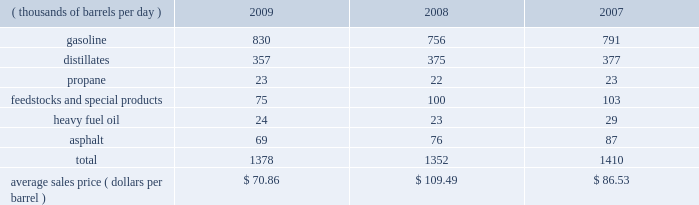The table sets forth our refined products sales by product group and our average sales price for each of the last three years .
Refined product sales ( thousands of barrels per day ) 2009 2008 2007 .
We sell gasoline , gasoline blendstocks and no .
1 and no .
2 fuel oils ( including kerosene , jet fuel and diesel fuel ) to wholesale marketing customers in the midwest , upper great plains , gulf coast and southeastern regions of the united states .
We sold 51 percent of our gasoline volumes and 87 percent of our distillates volumes on a wholesale or spot market basis in 2009 .
The demand for gasoline is seasonal in many of our markets , with demand typically being at its highest levels during the summer months .
We have blended ethanol into gasoline for over 20 years and began expanding our blending program in 2007 , in part due to federal regulations that require us to use specified volumes of renewable fuels .
Ethanol volumes sold in blended gasoline were 60 mbpd in 2009 , 54 mbpd in 2008 and 40 mbpd in 2007 .
The future expansion or contraction of our ethanol blending program will be driven by the economics of the ethanol supply and by government regulations .
We sell reformulated gasoline , which is also blended with ethanol , in parts of our marketing territory , including : chicago , illinois ; louisville , kentucky ; northern kentucky ; milwaukee , wisconsin , and hartford , illinois .
We also sell biodiesel-blended diesel in minnesota , illinois and kentucky .
We produce propane at all seven of our refineries .
Propane is primarily used for home heating and cooking , as a feedstock within the petrochemical industry , for grain drying and as a fuel for trucks and other vehicles .
Our propane sales are typically split evenly between the home heating market and industrial consumers .
We are a producer and marketer of petrochemicals and specialty products .
Product availability varies by refinery and includes benzene , cumene , dilute naphthalene oil , molten maleic anhydride , molten sulfur , propylene , toluene and xylene .
We market propylene , cumene and sulfur domestically to customers in the chemical industry .
We sell maleic anhydride throughout the united states and canada .
We also have the capacity to produce 1400 tons per day of anode grade coke at our robinson refinery , which is used to make carbon anodes for the aluminum smelting industry , and 5500 tons per day of fuel grade coke at the garyville refinery , which is used for power generation and in miscellaneous industrial applications .
In early 2009 , we discontinued production and sales of petroleum pitch and aliphatic solvents at our catlettsburg refinery .
We produce and market heavy residual fuel oil or related components at all seven of our refineries .
Another product of crude oil , heavy residual fuel oil , is primarily used in the utility and ship bunkering ( fuel ) industries , though there are other more specialized uses of the product .
We have refinery based asphalt production capacity of up to 108 mbpd .
We market asphalt through 33 owned or leased terminals throughout the midwest and southeast .
We have a broad customer base , including approximately 675 asphalt-paving contractors , government entities ( states , counties , cities and townships ) and asphalt roofing shingle manufacturers .
We sell asphalt in the wholesale and cargo markets via rail and barge .
We also produce asphalt cements , polymer modified asphalt , emulsified asphalt and industrial asphalts .
In 2007 , we acquired a 35 percent interest in an entity which owns and operates a 110-million-gallon-per-year ethanol production facility in clymers , indiana .
We also own a 50 percent interest in an entity which owns a 110-million-gallon-per-year ethanol production facility in greenville , ohio .
The greenville plant began production in february 2008 .
Both of these facilities are managed by a co-owner. .
What were total ethanol volumes sold in blended gasoline in 2009 , 2008 , and 2007 in tbd? 
Computations: ((60 + 54) + 40)
Answer: 154.0. The table sets forth our refined products sales by product group and our average sales price for each of the last three years .
Refined product sales ( thousands of barrels per day ) 2009 2008 2007 .
We sell gasoline , gasoline blendstocks and no .
1 and no .
2 fuel oils ( including kerosene , jet fuel and diesel fuel ) to wholesale marketing customers in the midwest , upper great plains , gulf coast and southeastern regions of the united states .
We sold 51 percent of our gasoline volumes and 87 percent of our distillates volumes on a wholesale or spot market basis in 2009 .
The demand for gasoline is seasonal in many of our markets , with demand typically being at its highest levels during the summer months .
We have blended ethanol into gasoline for over 20 years and began expanding our blending program in 2007 , in part due to federal regulations that require us to use specified volumes of renewable fuels .
Ethanol volumes sold in blended gasoline were 60 mbpd in 2009 , 54 mbpd in 2008 and 40 mbpd in 2007 .
The future expansion or contraction of our ethanol blending program will be driven by the economics of the ethanol supply and by government regulations .
We sell reformulated gasoline , which is also blended with ethanol , in parts of our marketing territory , including : chicago , illinois ; louisville , kentucky ; northern kentucky ; milwaukee , wisconsin , and hartford , illinois .
We also sell biodiesel-blended diesel in minnesota , illinois and kentucky .
We produce propane at all seven of our refineries .
Propane is primarily used for home heating and cooking , as a feedstock within the petrochemical industry , for grain drying and as a fuel for trucks and other vehicles .
Our propane sales are typically split evenly between the home heating market and industrial consumers .
We are a producer and marketer of petrochemicals and specialty products .
Product availability varies by refinery and includes benzene , cumene , dilute naphthalene oil , molten maleic anhydride , molten sulfur , propylene , toluene and xylene .
We market propylene , cumene and sulfur domestically to customers in the chemical industry .
We sell maleic anhydride throughout the united states and canada .
We also have the capacity to produce 1400 tons per day of anode grade coke at our robinson refinery , which is used to make carbon anodes for the aluminum smelting industry , and 5500 tons per day of fuel grade coke at the garyville refinery , which is used for power generation and in miscellaneous industrial applications .
In early 2009 , we discontinued production and sales of petroleum pitch and aliphatic solvents at our catlettsburg refinery .
We produce and market heavy residual fuel oil or related components at all seven of our refineries .
Another product of crude oil , heavy residual fuel oil , is primarily used in the utility and ship bunkering ( fuel ) industries , though there are other more specialized uses of the product .
We have refinery based asphalt production capacity of up to 108 mbpd .
We market asphalt through 33 owned or leased terminals throughout the midwest and southeast .
We have a broad customer base , including approximately 675 asphalt-paving contractors , government entities ( states , counties , cities and townships ) and asphalt roofing shingle manufacturers .
We sell asphalt in the wholesale and cargo markets via rail and barge .
We also produce asphalt cements , polymer modified asphalt , emulsified asphalt and industrial asphalts .
In 2007 , we acquired a 35 percent interest in an entity which owns and operates a 110-million-gallon-per-year ethanol production facility in clymers , indiana .
We also own a 50 percent interest in an entity which owns a 110-million-gallon-per-year ethanol production facility in greenville , ohio .
The greenville plant began production in february 2008 .
Both of these facilities are managed by a co-owner. .
What percentage of refined product sales consisted of asphalt in 2009? 
Computations: (69 / 1378)
Answer: 0.05007. The table sets forth our refined products sales by product group and our average sales price for each of the last three years .
Refined product sales ( thousands of barrels per day ) 2009 2008 2007 .
We sell gasoline , gasoline blendstocks and no .
1 and no .
2 fuel oils ( including kerosene , jet fuel and diesel fuel ) to wholesale marketing customers in the midwest , upper great plains , gulf coast and southeastern regions of the united states .
We sold 51 percent of our gasoline volumes and 87 percent of our distillates volumes on a wholesale or spot market basis in 2009 .
The demand for gasoline is seasonal in many of our markets , with demand typically being at its highest levels during the summer months .
We have blended ethanol into gasoline for over 20 years and began expanding our blending program in 2007 , in part due to federal regulations that require us to use specified volumes of renewable fuels .
Ethanol volumes sold in blended gasoline were 60 mbpd in 2009 , 54 mbpd in 2008 and 40 mbpd in 2007 .
The future expansion or contraction of our ethanol blending program will be driven by the economics of the ethanol supply and by government regulations .
We sell reformulated gasoline , which is also blended with ethanol , in parts of our marketing territory , including : chicago , illinois ; louisville , kentucky ; northern kentucky ; milwaukee , wisconsin , and hartford , illinois .
We also sell biodiesel-blended diesel in minnesota , illinois and kentucky .
We produce propane at all seven of our refineries .
Propane is primarily used for home heating and cooking , as a feedstock within the petrochemical industry , for grain drying and as a fuel for trucks and other vehicles .
Our propane sales are typically split evenly between the home heating market and industrial consumers .
We are a producer and marketer of petrochemicals and specialty products .
Product availability varies by refinery and includes benzene , cumene , dilute naphthalene oil , molten maleic anhydride , molten sulfur , propylene , toluene and xylene .
We market propylene , cumene and sulfur domestically to customers in the chemical industry .
We sell maleic anhydride throughout the united states and canada .
We also have the capacity to produce 1400 tons per day of anode grade coke at our robinson refinery , which is used to make carbon anodes for the aluminum smelting industry , and 5500 tons per day of fuel grade coke at the garyville refinery , which is used for power generation and in miscellaneous industrial applications .
In early 2009 , we discontinued production and sales of petroleum pitch and aliphatic solvents at our catlettsburg refinery .
We produce and market heavy residual fuel oil or related components at all seven of our refineries .
Another product of crude oil , heavy residual fuel oil , is primarily used in the utility and ship bunkering ( fuel ) industries , though there are other more specialized uses of the product .
We have refinery based asphalt production capacity of up to 108 mbpd .
We market asphalt through 33 owned or leased terminals throughout the midwest and southeast .
We have a broad customer base , including approximately 675 asphalt-paving contractors , government entities ( states , counties , cities and townships ) and asphalt roofing shingle manufacturers .
We sell asphalt in the wholesale and cargo markets via rail and barge .
We also produce asphalt cements , polymer modified asphalt , emulsified asphalt and industrial asphalts .
In 2007 , we acquired a 35 percent interest in an entity which owns and operates a 110-million-gallon-per-year ethanol production facility in clymers , indiana .
We also own a 50 percent interest in an entity which owns a 110-million-gallon-per-year ethanol production facility in greenville , ohio .
The greenville plant began production in february 2008 .
Both of these facilities are managed by a co-owner. .
What percentage of refined product sales consisted of distillates in 2008? 
Computations: (375 / 1352)
Answer: 0.27737. 